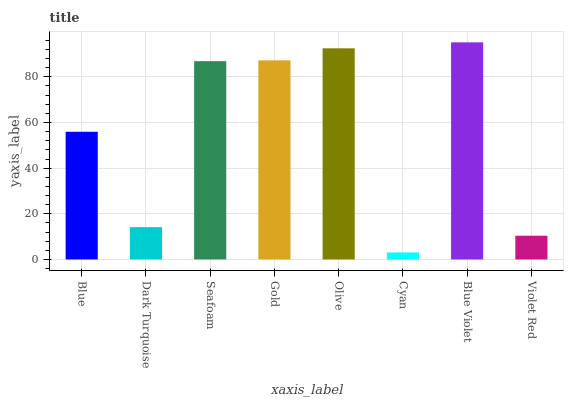Is Cyan the minimum?
Answer yes or no. Yes. Is Blue Violet the maximum?
Answer yes or no. Yes. Is Dark Turquoise the minimum?
Answer yes or no. No. Is Dark Turquoise the maximum?
Answer yes or no. No. Is Blue greater than Dark Turquoise?
Answer yes or no. Yes. Is Dark Turquoise less than Blue?
Answer yes or no. Yes. Is Dark Turquoise greater than Blue?
Answer yes or no. No. Is Blue less than Dark Turquoise?
Answer yes or no. No. Is Seafoam the high median?
Answer yes or no. Yes. Is Blue the low median?
Answer yes or no. Yes. Is Olive the high median?
Answer yes or no. No. Is Gold the low median?
Answer yes or no. No. 